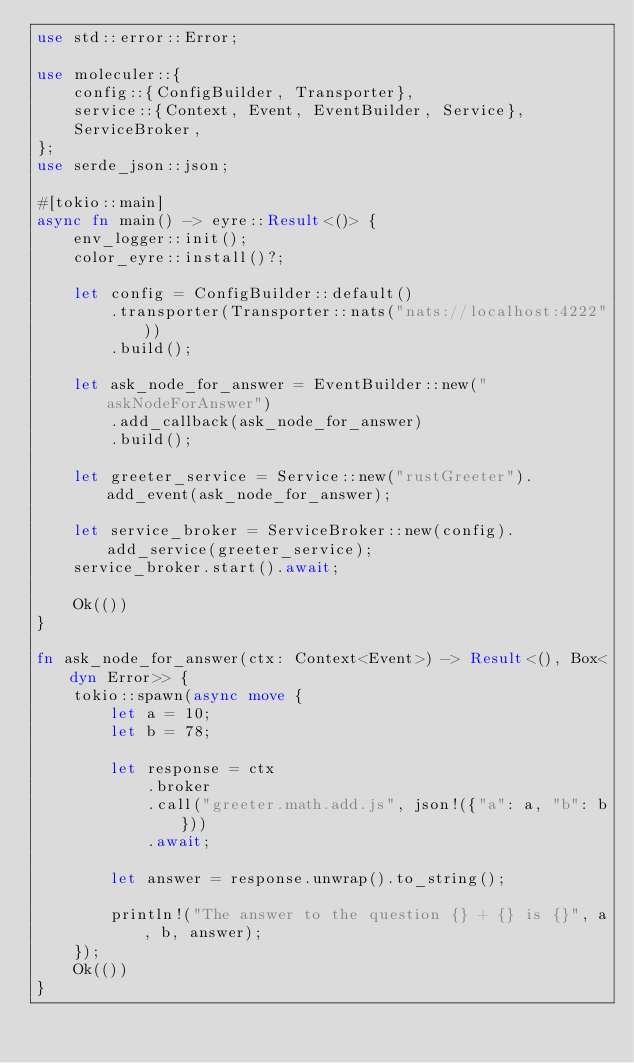<code> <loc_0><loc_0><loc_500><loc_500><_Rust_>use std::error::Error;

use moleculer::{
    config::{ConfigBuilder, Transporter},
    service::{Context, Event, EventBuilder, Service},
    ServiceBroker,
};
use serde_json::json;

#[tokio::main]
async fn main() -> eyre::Result<()> {
    env_logger::init();
    color_eyre::install()?;

    let config = ConfigBuilder::default()
        .transporter(Transporter::nats("nats://localhost:4222"))
        .build();

    let ask_node_for_answer = EventBuilder::new("askNodeForAnswer")
        .add_callback(ask_node_for_answer)
        .build();

    let greeter_service = Service::new("rustGreeter").add_event(ask_node_for_answer);

    let service_broker = ServiceBroker::new(config).add_service(greeter_service);
    service_broker.start().await;

    Ok(())
}

fn ask_node_for_answer(ctx: Context<Event>) -> Result<(), Box<dyn Error>> {
    tokio::spawn(async move {
        let a = 10;
        let b = 78;

        let response = ctx
            .broker
            .call("greeter.math.add.js", json!({"a": a, "b": b}))
            .await;

        let answer = response.unwrap().to_string();

        println!("The answer to the question {} + {} is {}", a, b, answer);
    });
    Ok(())
}
</code> 